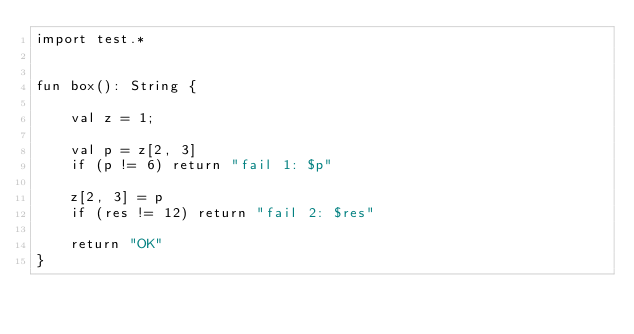Convert code to text. <code><loc_0><loc_0><loc_500><loc_500><_Kotlin_>import test.*


fun box(): String {

    val z = 1;

    val p = z[2, 3]
    if (p != 6) return "fail 1: $p"

    z[2, 3] = p
    if (res != 12) return "fail 2: $res"

    return "OK"
}</code> 